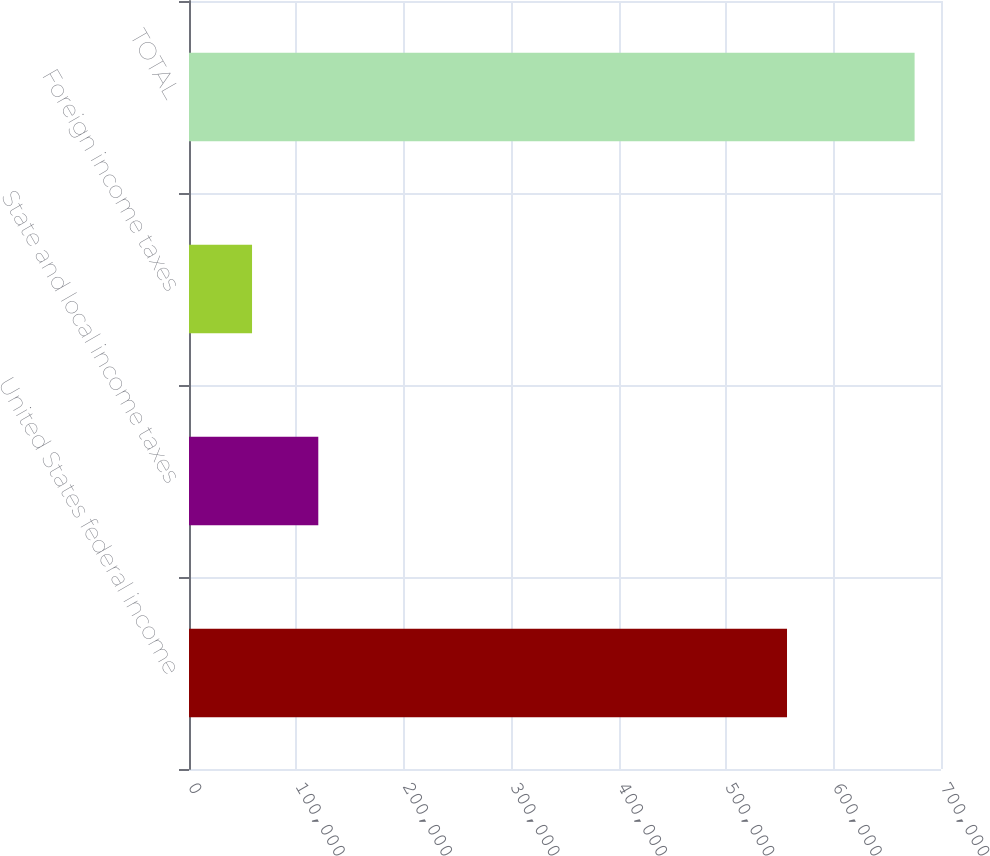Convert chart to OTSL. <chart><loc_0><loc_0><loc_500><loc_500><bar_chart><fcel>United States federal income<fcel>State and local income taxes<fcel>Foreign income taxes<fcel>TOTAL<nl><fcel>556663<fcel>120354<fcel>58680<fcel>675424<nl></chart> 